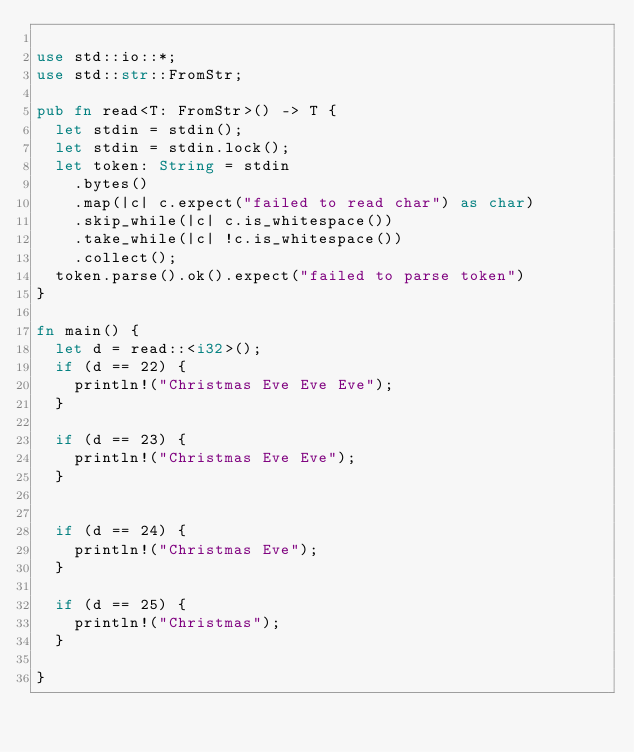Convert code to text. <code><loc_0><loc_0><loc_500><loc_500><_Rust_>
use std::io::*;
use std::str::FromStr;

pub fn read<T: FromStr>() -> T {
  let stdin = stdin();
  let stdin = stdin.lock();
  let token: String = stdin
    .bytes()
    .map(|c| c.expect("failed to read char") as char)
    .skip_while(|c| c.is_whitespace())
    .take_while(|c| !c.is_whitespace())
    .collect();
  token.parse().ok().expect("failed to parse token")
}

fn main() {
  let d = read::<i32>();
  if (d == 22) {
    println!("Christmas Eve Eve Eve");
  }

  if (d == 23) {
    println!("Christmas Eve Eve");
  }


  if (d == 24) {
    println!("Christmas Eve");
  }

  if (d == 25) {
    println!("Christmas");
  }

}

</code> 